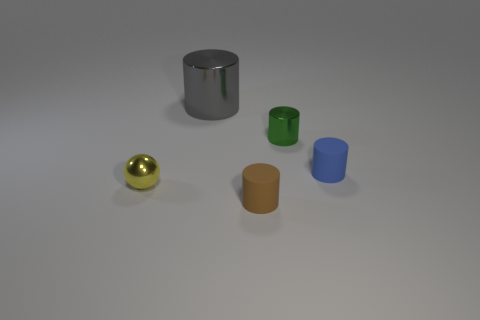Subtract all small cylinders. How many cylinders are left? 1 Add 5 big gray metallic objects. How many objects exist? 10 Subtract all cylinders. How many objects are left? 1 Subtract all green cylinders. How many cylinders are left? 3 Add 2 small metallic cylinders. How many small metallic cylinders exist? 3 Subtract 0 purple blocks. How many objects are left? 5 Subtract 1 cylinders. How many cylinders are left? 3 Subtract all green cylinders. Subtract all red balls. How many cylinders are left? 3 Subtract all brown spheres. How many purple cylinders are left? 0 Subtract all cylinders. Subtract all large brown balls. How many objects are left? 1 